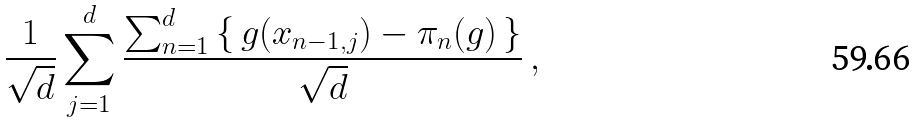Convert formula to latex. <formula><loc_0><loc_0><loc_500><loc_500>\frac { 1 } { \sqrt { d } } \sum _ { j = 1 } ^ { d } \frac { \sum _ { n = 1 } ^ { d } \, \{ \, g ( x _ { n - 1 , j } ) - \pi _ { n } ( g ) \, \} } { \sqrt { d } } \, ,</formula> 